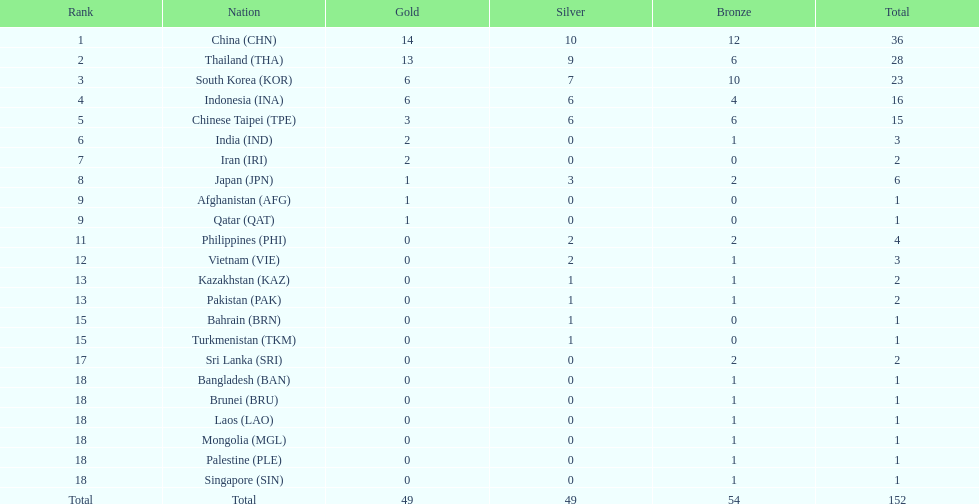How many nations received a medal in each gold, silver, and bronze? 6. 